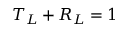Convert formula to latex. <formula><loc_0><loc_0><loc_500><loc_500>T _ { L } + R _ { L } = 1</formula> 